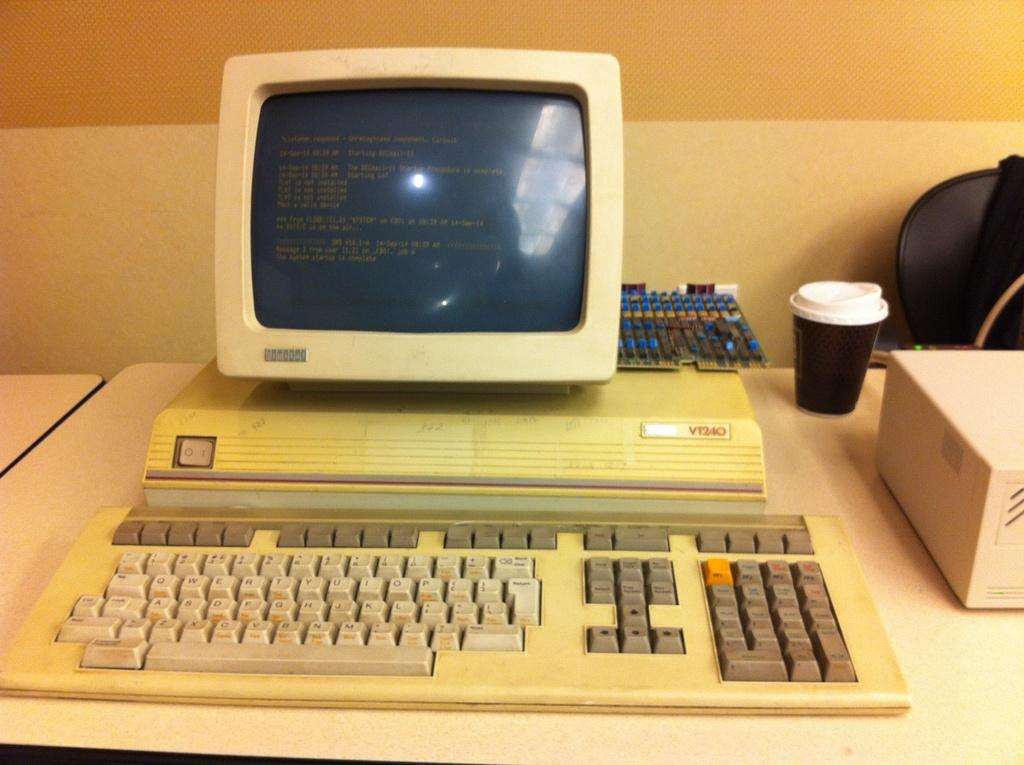<image>
Present a compact description of the photo's key features. A discolored computer terminal is identified as model VT240. 